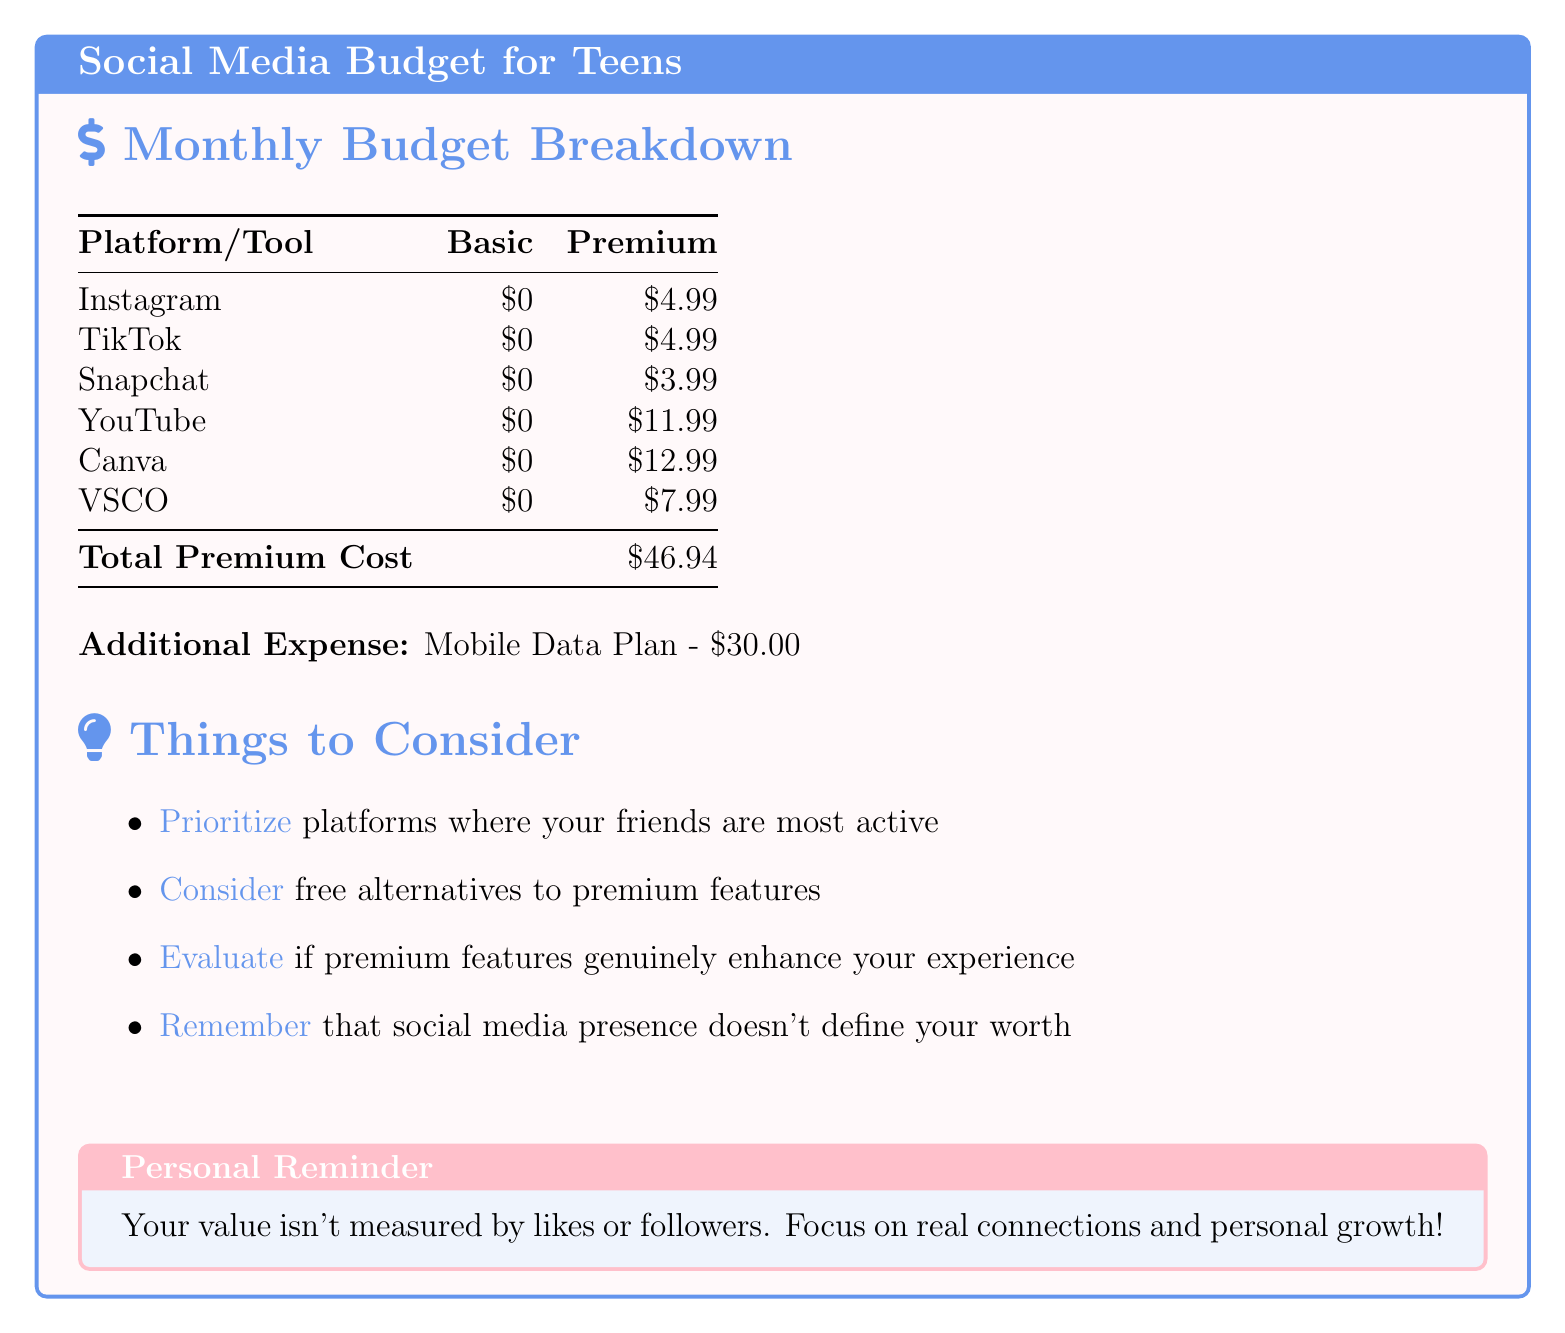What is the monthly premium cost for Instagram? The monthly premium cost for Instagram is listed in the table under the "Premium" column, which is $4.99.
Answer: $4.99 How much is the monthly premium for YouTube? The document lists the monthly premium for YouTube in the table as $11.99.
Answer: $11.99 What is the total premium cost for all subscriptions? The total premium cost is the sum of all premium subscriptions provided in the table, which equals $46.94.
Answer: $46.94 What is the additional expense mentioned in the document? The additional expense is explicitly stated after the table, which is the Mobile Data Plan costing $30.00.
Answer: $30.00 Which platform has the highest premium cost? The platform with the highest premium cost can be identified by looking at the values in the "Premium" column, which is YouTube with $11.99.
Answer: YouTube How should you evaluate premium features? The document suggests evaluating premium features by assessing if they genuinely enhance your experience, indicated in the "Things to Consider" section.
Answer: If they enhance your experience What is the primary focus of the personal reminder section? The personal reminder section emphasizes the idea that your value isn't based on likes or followers, which is a key takeaway.
Answer: Your value isn't measured by likes or followers What is the premium cost of Snapchat? The premium cost for Snapchat can be found in the table under "Premium," which is $3.99.
Answer: $3.99 